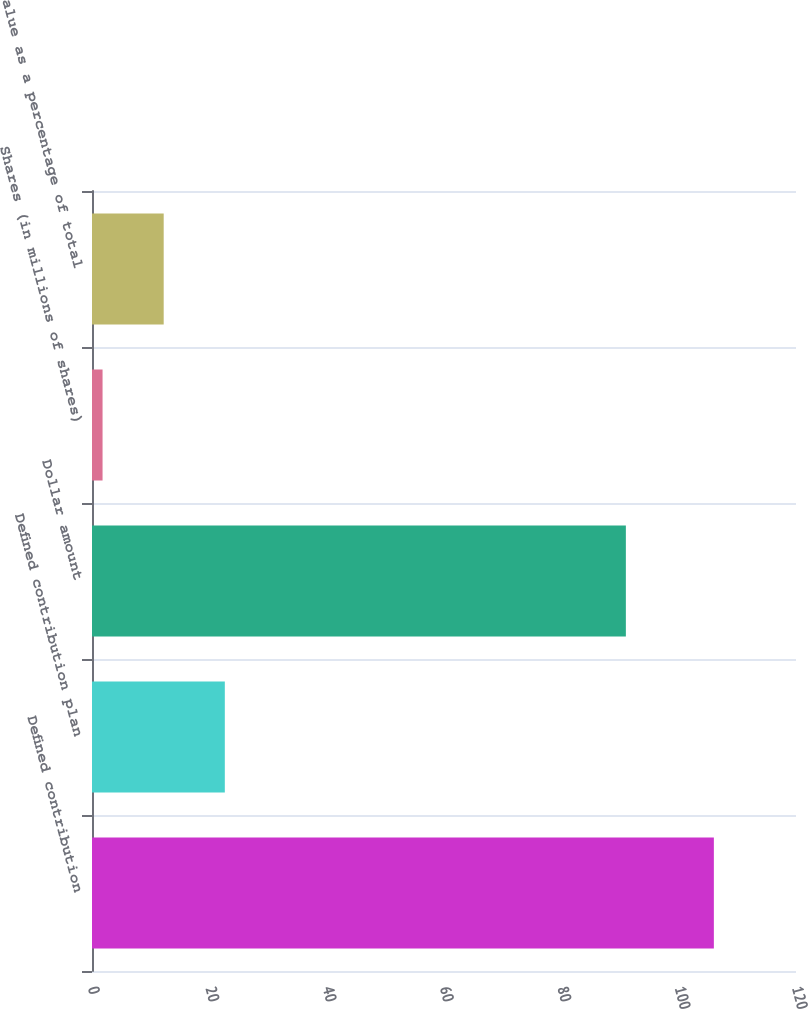<chart> <loc_0><loc_0><loc_500><loc_500><bar_chart><fcel>Defined contribution<fcel>Defined contribution plan<fcel>Dollar amount<fcel>Shares (in millions of shares)<fcel>Value as a percentage of total<nl><fcel>106<fcel>22.64<fcel>91<fcel>1.8<fcel>12.22<nl></chart> 